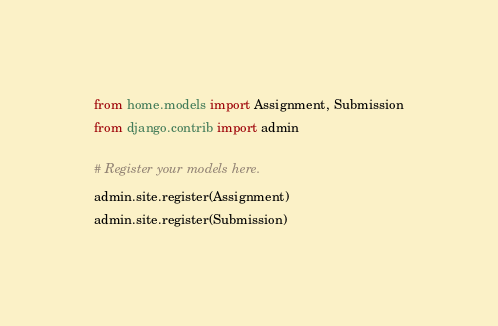<code> <loc_0><loc_0><loc_500><loc_500><_Python_>from home.models import Assignment, Submission
from django.contrib import admin

# Register your models here.
admin.site.register(Assignment)
admin.site.register(Submission)</code> 